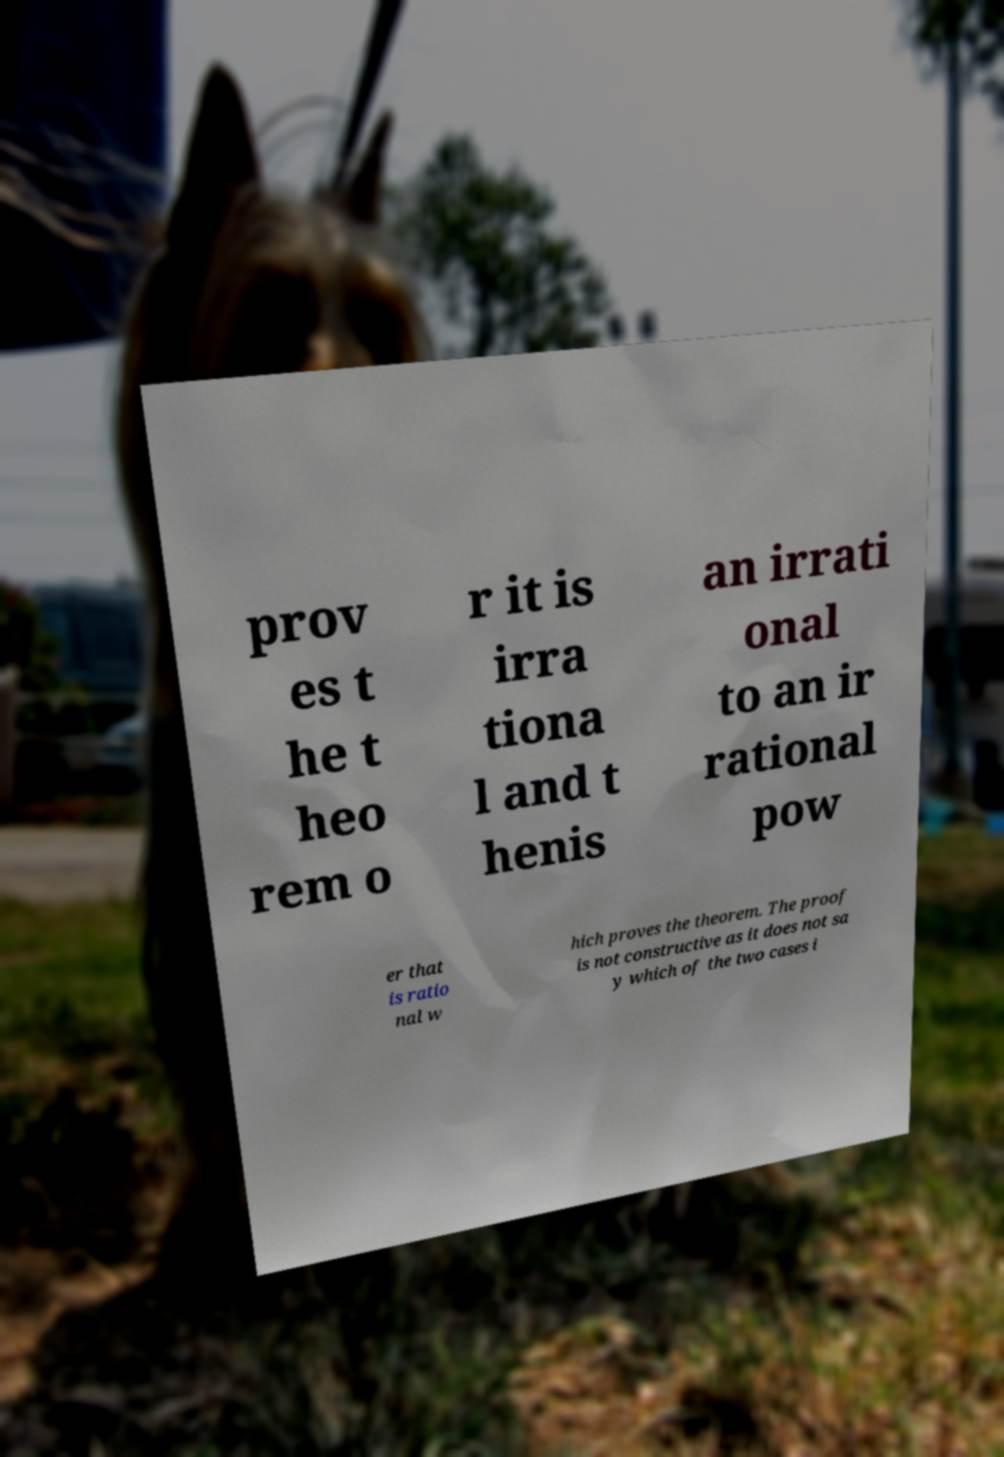For documentation purposes, I need the text within this image transcribed. Could you provide that? prov es t he t heo rem o r it is irra tiona l and t henis an irrati onal to an ir rational pow er that is ratio nal w hich proves the theorem. The proof is not constructive as it does not sa y which of the two cases i 